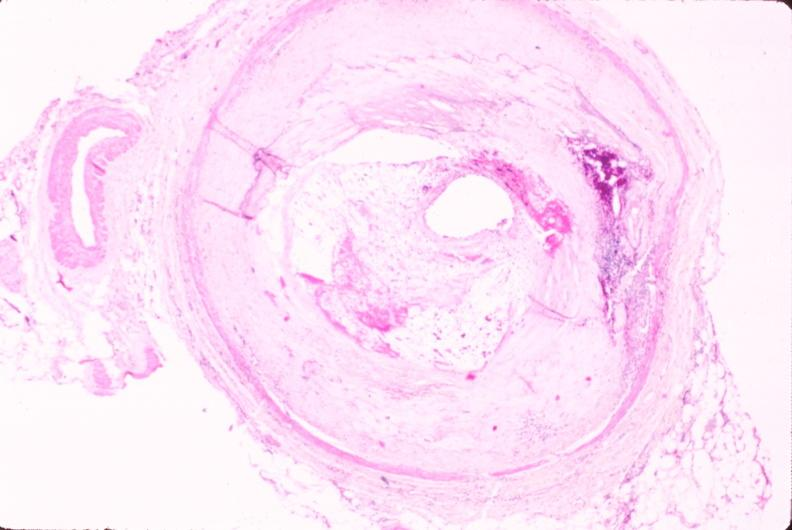does this image show atherosclerosis?
Answer the question using a single word or phrase. Yes 